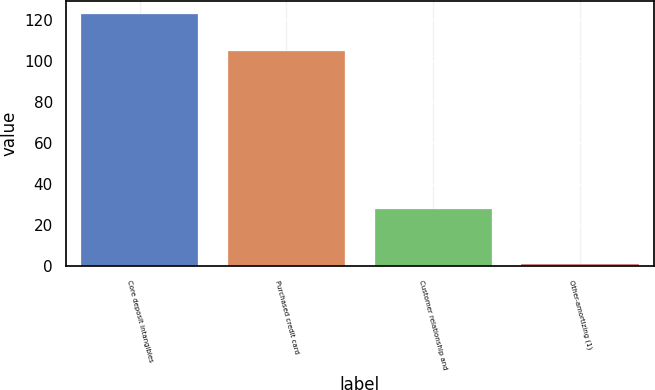Convert chart. <chart><loc_0><loc_0><loc_500><loc_500><bar_chart><fcel>Core deposit intangibles<fcel>Purchased credit card<fcel>Customer relationship and<fcel>Other-amortizing (1)<nl><fcel>123<fcel>105<fcel>28<fcel>1<nl></chart> 